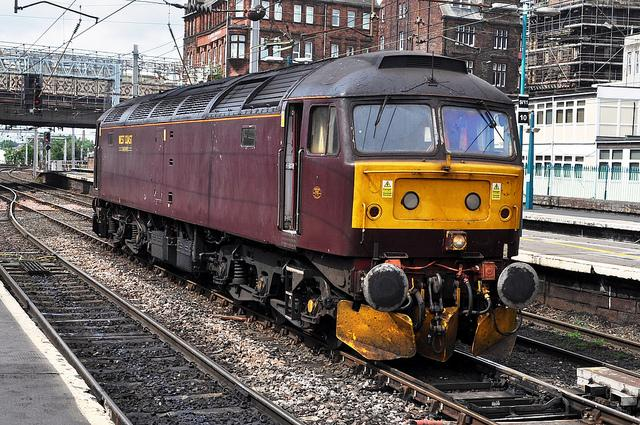What type of area is in the background? Please explain your reasoning. urban. The background appears to have apartment buildings and other metropolitan buildings based on their size and design which would be consistent with answer a. 